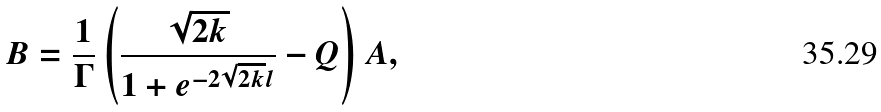Convert formula to latex. <formula><loc_0><loc_0><loc_500><loc_500>B = \frac { 1 } { \Gamma } \left ( \frac { \sqrt { 2 k } } { 1 + e ^ { - 2 \sqrt { 2 k } l } } - Q \right ) A ,</formula> 